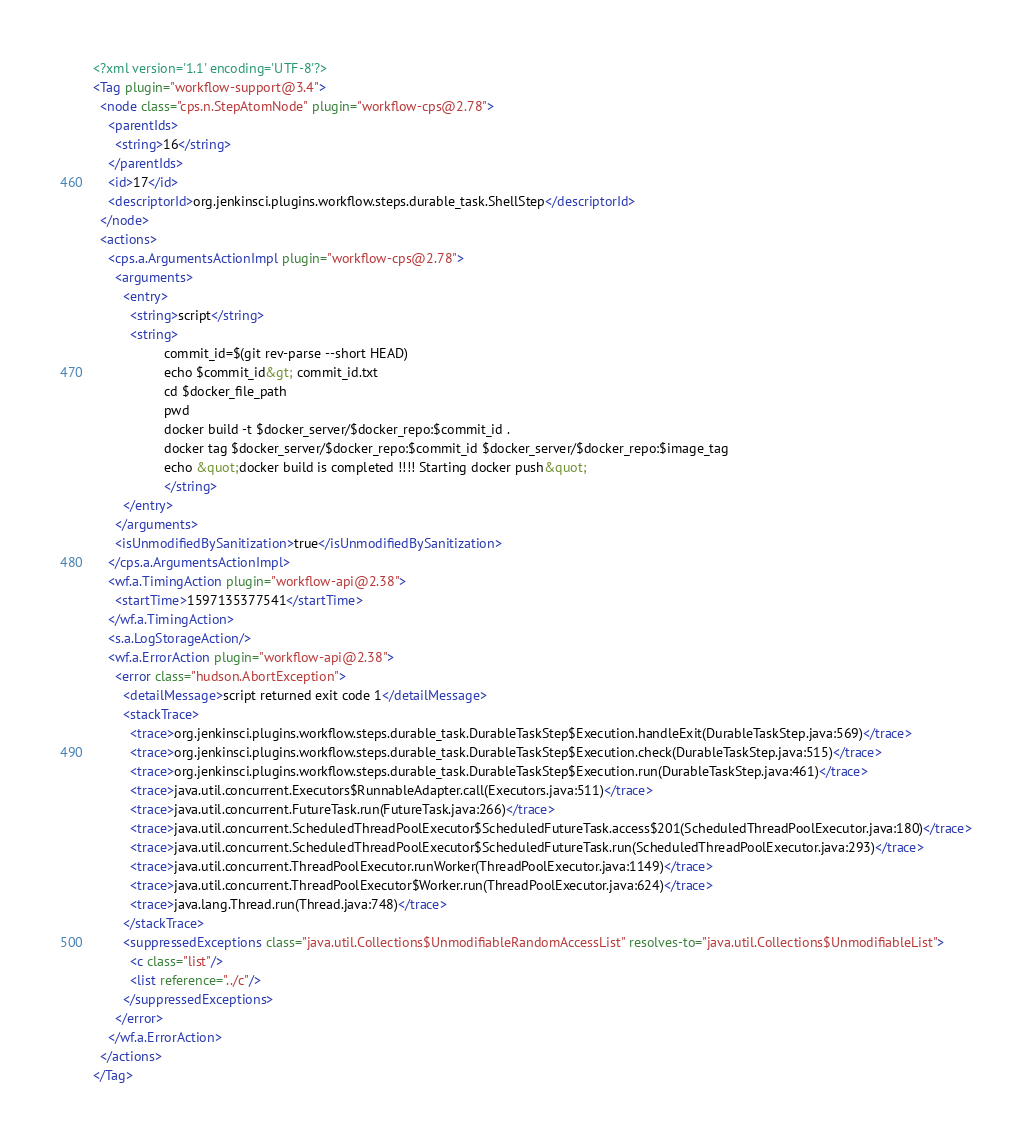<code> <loc_0><loc_0><loc_500><loc_500><_XML_><?xml version='1.1' encoding='UTF-8'?>
<Tag plugin="workflow-support@3.4">
  <node class="cps.n.StepAtomNode" plugin="workflow-cps@2.78">
    <parentIds>
      <string>16</string>
    </parentIds>
    <id>17</id>
    <descriptorId>org.jenkinsci.plugins.workflow.steps.durable_task.ShellStep</descriptorId>
  </node>
  <actions>
    <cps.a.ArgumentsActionImpl plugin="workflow-cps@2.78">
      <arguments>
        <entry>
          <string>script</string>
          <string>
                   commit_id=$(git rev-parse --short HEAD)
                   echo $commit_id&gt; commit_id.txt
                   cd $docker_file_path
                   pwd
                   docker build -t $docker_server/$docker_repo:$commit_id .
                   docker tag $docker_server/$docker_repo:$commit_id $docker_server/$docker_repo:$image_tag
                   echo &quot;docker build is completed !!!! Starting docker push&quot;
                   </string>
        </entry>
      </arguments>
      <isUnmodifiedBySanitization>true</isUnmodifiedBySanitization>
    </cps.a.ArgumentsActionImpl>
    <wf.a.TimingAction plugin="workflow-api@2.38">
      <startTime>1597135377541</startTime>
    </wf.a.TimingAction>
    <s.a.LogStorageAction/>
    <wf.a.ErrorAction plugin="workflow-api@2.38">
      <error class="hudson.AbortException">
        <detailMessage>script returned exit code 1</detailMessage>
        <stackTrace>
          <trace>org.jenkinsci.plugins.workflow.steps.durable_task.DurableTaskStep$Execution.handleExit(DurableTaskStep.java:569)</trace>
          <trace>org.jenkinsci.plugins.workflow.steps.durable_task.DurableTaskStep$Execution.check(DurableTaskStep.java:515)</trace>
          <trace>org.jenkinsci.plugins.workflow.steps.durable_task.DurableTaskStep$Execution.run(DurableTaskStep.java:461)</trace>
          <trace>java.util.concurrent.Executors$RunnableAdapter.call(Executors.java:511)</trace>
          <trace>java.util.concurrent.FutureTask.run(FutureTask.java:266)</trace>
          <trace>java.util.concurrent.ScheduledThreadPoolExecutor$ScheduledFutureTask.access$201(ScheduledThreadPoolExecutor.java:180)</trace>
          <trace>java.util.concurrent.ScheduledThreadPoolExecutor$ScheduledFutureTask.run(ScheduledThreadPoolExecutor.java:293)</trace>
          <trace>java.util.concurrent.ThreadPoolExecutor.runWorker(ThreadPoolExecutor.java:1149)</trace>
          <trace>java.util.concurrent.ThreadPoolExecutor$Worker.run(ThreadPoolExecutor.java:624)</trace>
          <trace>java.lang.Thread.run(Thread.java:748)</trace>
        </stackTrace>
        <suppressedExceptions class="java.util.Collections$UnmodifiableRandomAccessList" resolves-to="java.util.Collections$UnmodifiableList">
          <c class="list"/>
          <list reference="../c"/>
        </suppressedExceptions>
      </error>
    </wf.a.ErrorAction>
  </actions>
</Tag></code> 